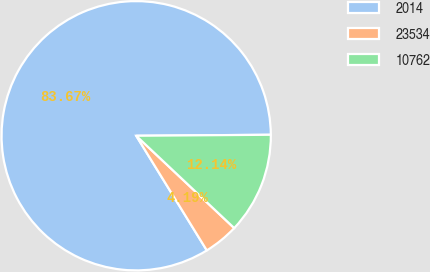Convert chart. <chart><loc_0><loc_0><loc_500><loc_500><pie_chart><fcel>2014<fcel>23534<fcel>10762<nl><fcel>83.67%<fcel>4.19%<fcel>12.14%<nl></chart> 